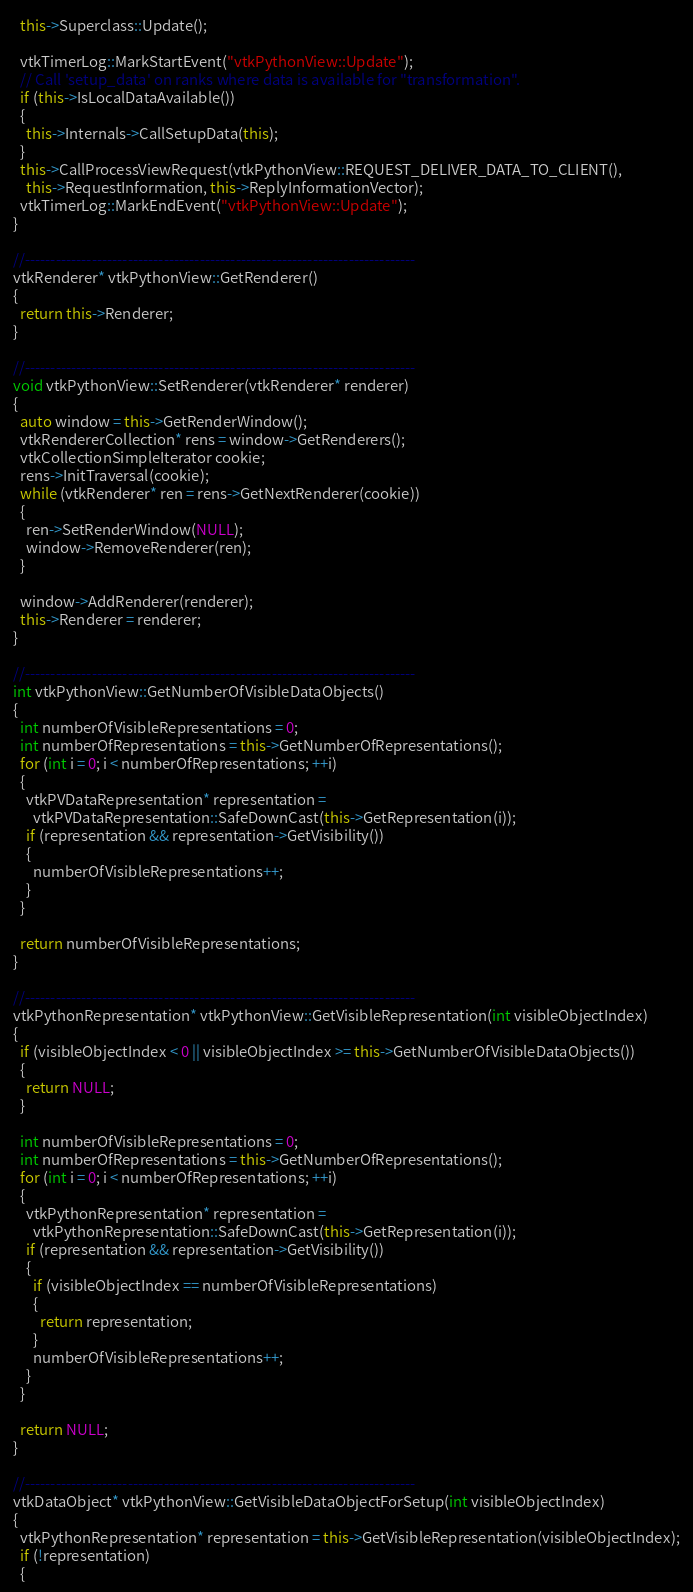<code> <loc_0><loc_0><loc_500><loc_500><_C++_>
  this->Superclass::Update();

  vtkTimerLog::MarkStartEvent("vtkPythonView::Update");
  // Call 'setup_data' on ranks where data is available for "transformation".
  if (this->IsLocalDataAvailable())
  {
    this->Internals->CallSetupData(this);
  }
  this->CallProcessViewRequest(vtkPythonView::REQUEST_DELIVER_DATA_TO_CLIENT(),
    this->RequestInformation, this->ReplyInformationVector);
  vtkTimerLog::MarkEndEvent("vtkPythonView::Update");
}

//----------------------------------------------------------------------------
vtkRenderer* vtkPythonView::GetRenderer()
{
  return this->Renderer;
}

//----------------------------------------------------------------------------
void vtkPythonView::SetRenderer(vtkRenderer* renderer)
{
  auto window = this->GetRenderWindow();
  vtkRendererCollection* rens = window->GetRenderers();
  vtkCollectionSimpleIterator cookie;
  rens->InitTraversal(cookie);
  while (vtkRenderer* ren = rens->GetNextRenderer(cookie))
  {
    ren->SetRenderWindow(NULL);
    window->RemoveRenderer(ren);
  }

  window->AddRenderer(renderer);
  this->Renderer = renderer;
}

//----------------------------------------------------------------------------
int vtkPythonView::GetNumberOfVisibleDataObjects()
{
  int numberOfVisibleRepresentations = 0;
  int numberOfRepresentations = this->GetNumberOfRepresentations();
  for (int i = 0; i < numberOfRepresentations; ++i)
  {
    vtkPVDataRepresentation* representation =
      vtkPVDataRepresentation::SafeDownCast(this->GetRepresentation(i));
    if (representation && representation->GetVisibility())
    {
      numberOfVisibleRepresentations++;
    }
  }

  return numberOfVisibleRepresentations;
}

//----------------------------------------------------------------------------
vtkPythonRepresentation* vtkPythonView::GetVisibleRepresentation(int visibleObjectIndex)
{
  if (visibleObjectIndex < 0 || visibleObjectIndex >= this->GetNumberOfVisibleDataObjects())
  {
    return NULL;
  }

  int numberOfVisibleRepresentations = 0;
  int numberOfRepresentations = this->GetNumberOfRepresentations();
  for (int i = 0; i < numberOfRepresentations; ++i)
  {
    vtkPythonRepresentation* representation =
      vtkPythonRepresentation::SafeDownCast(this->GetRepresentation(i));
    if (representation && representation->GetVisibility())
    {
      if (visibleObjectIndex == numberOfVisibleRepresentations)
      {
        return representation;
      }
      numberOfVisibleRepresentations++;
    }
  }

  return NULL;
}

//----------------------------------------------------------------------------
vtkDataObject* vtkPythonView::GetVisibleDataObjectForSetup(int visibleObjectIndex)
{
  vtkPythonRepresentation* representation = this->GetVisibleRepresentation(visibleObjectIndex);
  if (!representation)
  {</code> 